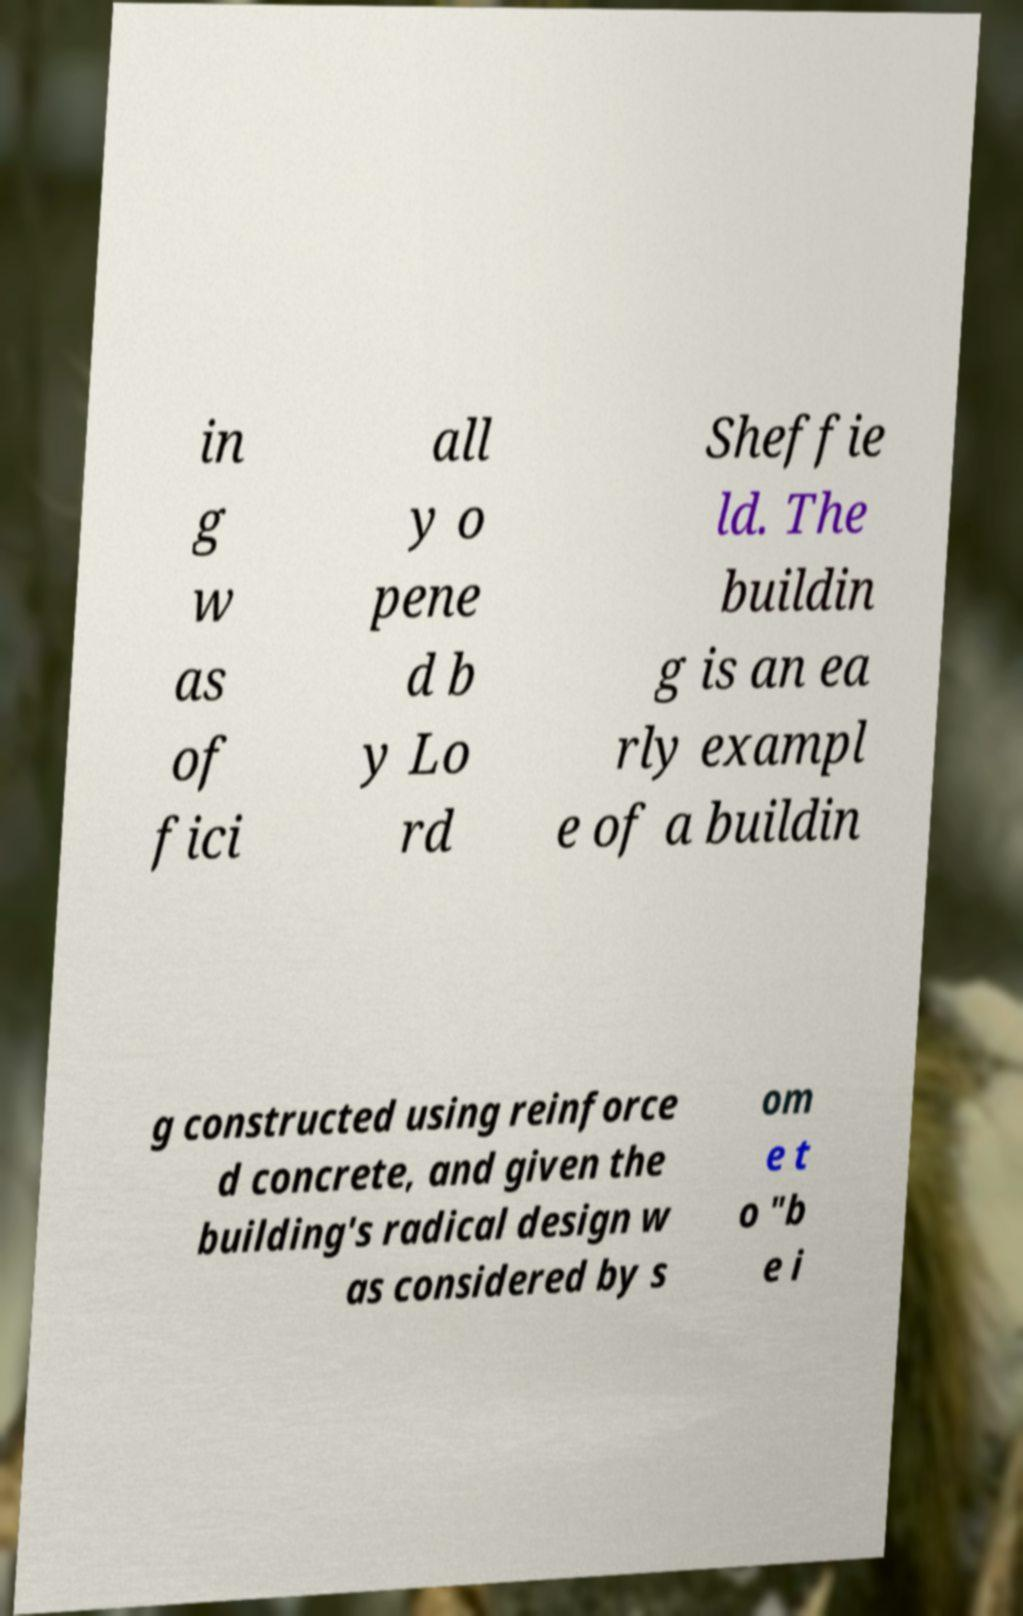What messages or text are displayed in this image? I need them in a readable, typed format. in g w as of fici all y o pene d b y Lo rd Sheffie ld. The buildin g is an ea rly exampl e of a buildin g constructed using reinforce d concrete, and given the building's radical design w as considered by s om e t o "b e i 